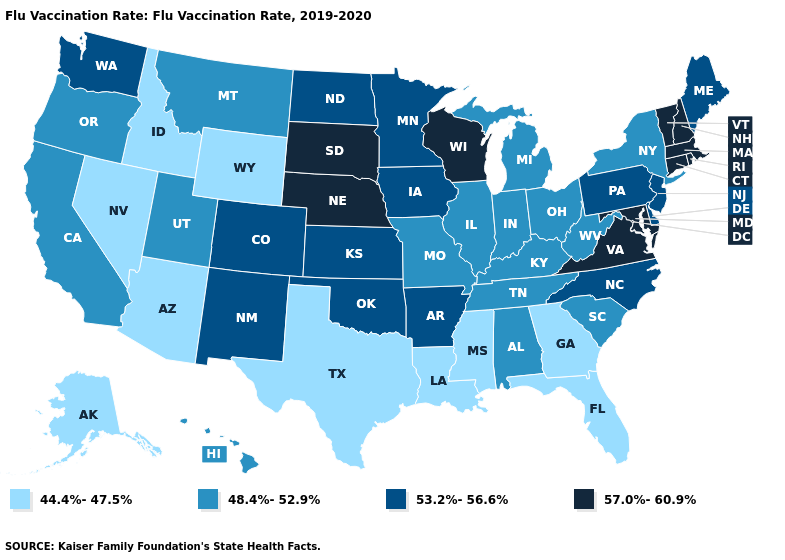Name the states that have a value in the range 57.0%-60.9%?
Short answer required. Connecticut, Maryland, Massachusetts, Nebraska, New Hampshire, Rhode Island, South Dakota, Vermont, Virginia, Wisconsin. Does Maryland have the highest value in the South?
Be succinct. Yes. What is the value of Wyoming?
Keep it brief. 44.4%-47.5%. Name the states that have a value in the range 57.0%-60.9%?
Concise answer only. Connecticut, Maryland, Massachusetts, Nebraska, New Hampshire, Rhode Island, South Dakota, Vermont, Virginia, Wisconsin. Does Rhode Island have the lowest value in the USA?
Write a very short answer. No. Among the states that border South Carolina , which have the lowest value?
Short answer required. Georgia. Among the states that border Iowa , which have the highest value?
Short answer required. Nebraska, South Dakota, Wisconsin. Does Maryland have the same value as West Virginia?
Write a very short answer. No. What is the value of Kentucky?
Short answer required. 48.4%-52.9%. What is the value of North Carolina?
Answer briefly. 53.2%-56.6%. What is the value of New Hampshire?
Short answer required. 57.0%-60.9%. Does the first symbol in the legend represent the smallest category?
Short answer required. Yes. Does Connecticut have the highest value in the Northeast?
Keep it brief. Yes. Among the states that border South Dakota , which have the lowest value?
Concise answer only. Wyoming. What is the lowest value in the MidWest?
Quick response, please. 48.4%-52.9%. 